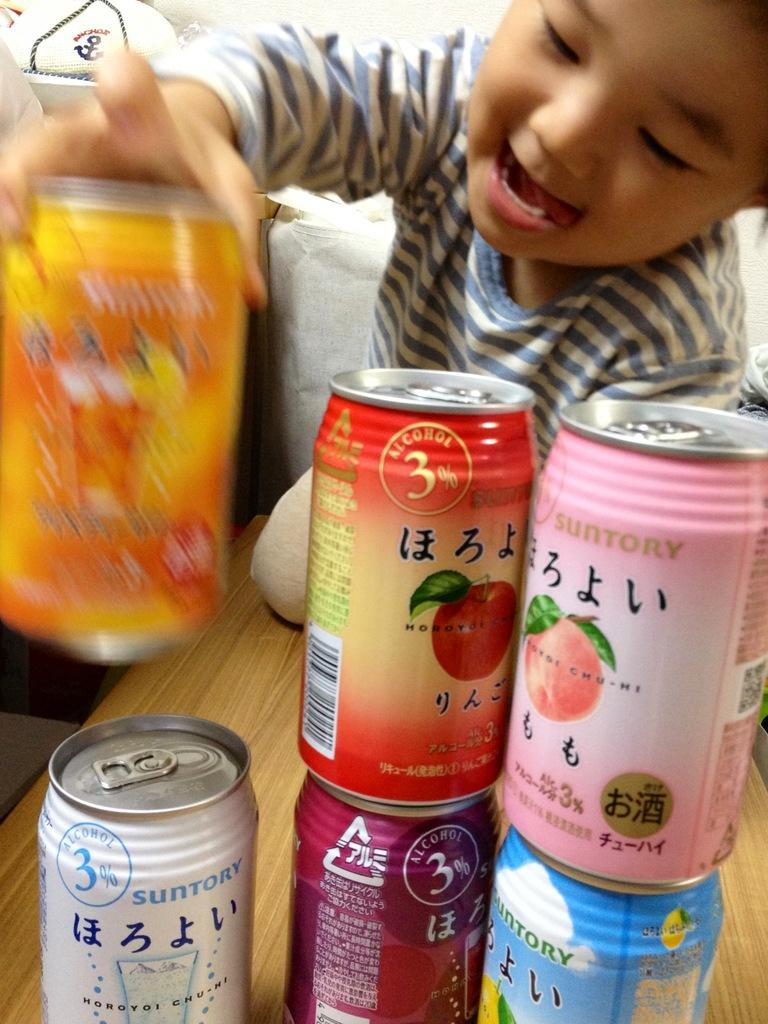Who is the main subject in the image? There is a boy in the image. What is the boy sitting on? The boy is sitting on a wooden surface. What is the boy doing in the image? The boy is arranging cans. Can you describe the cloth in the image? There is a cloth at the top left of the image. What type of zinc can be seen in the image? There is no zinc present in the image. Can you describe the air quality in the image? The image does not provide any information about the air quality. 